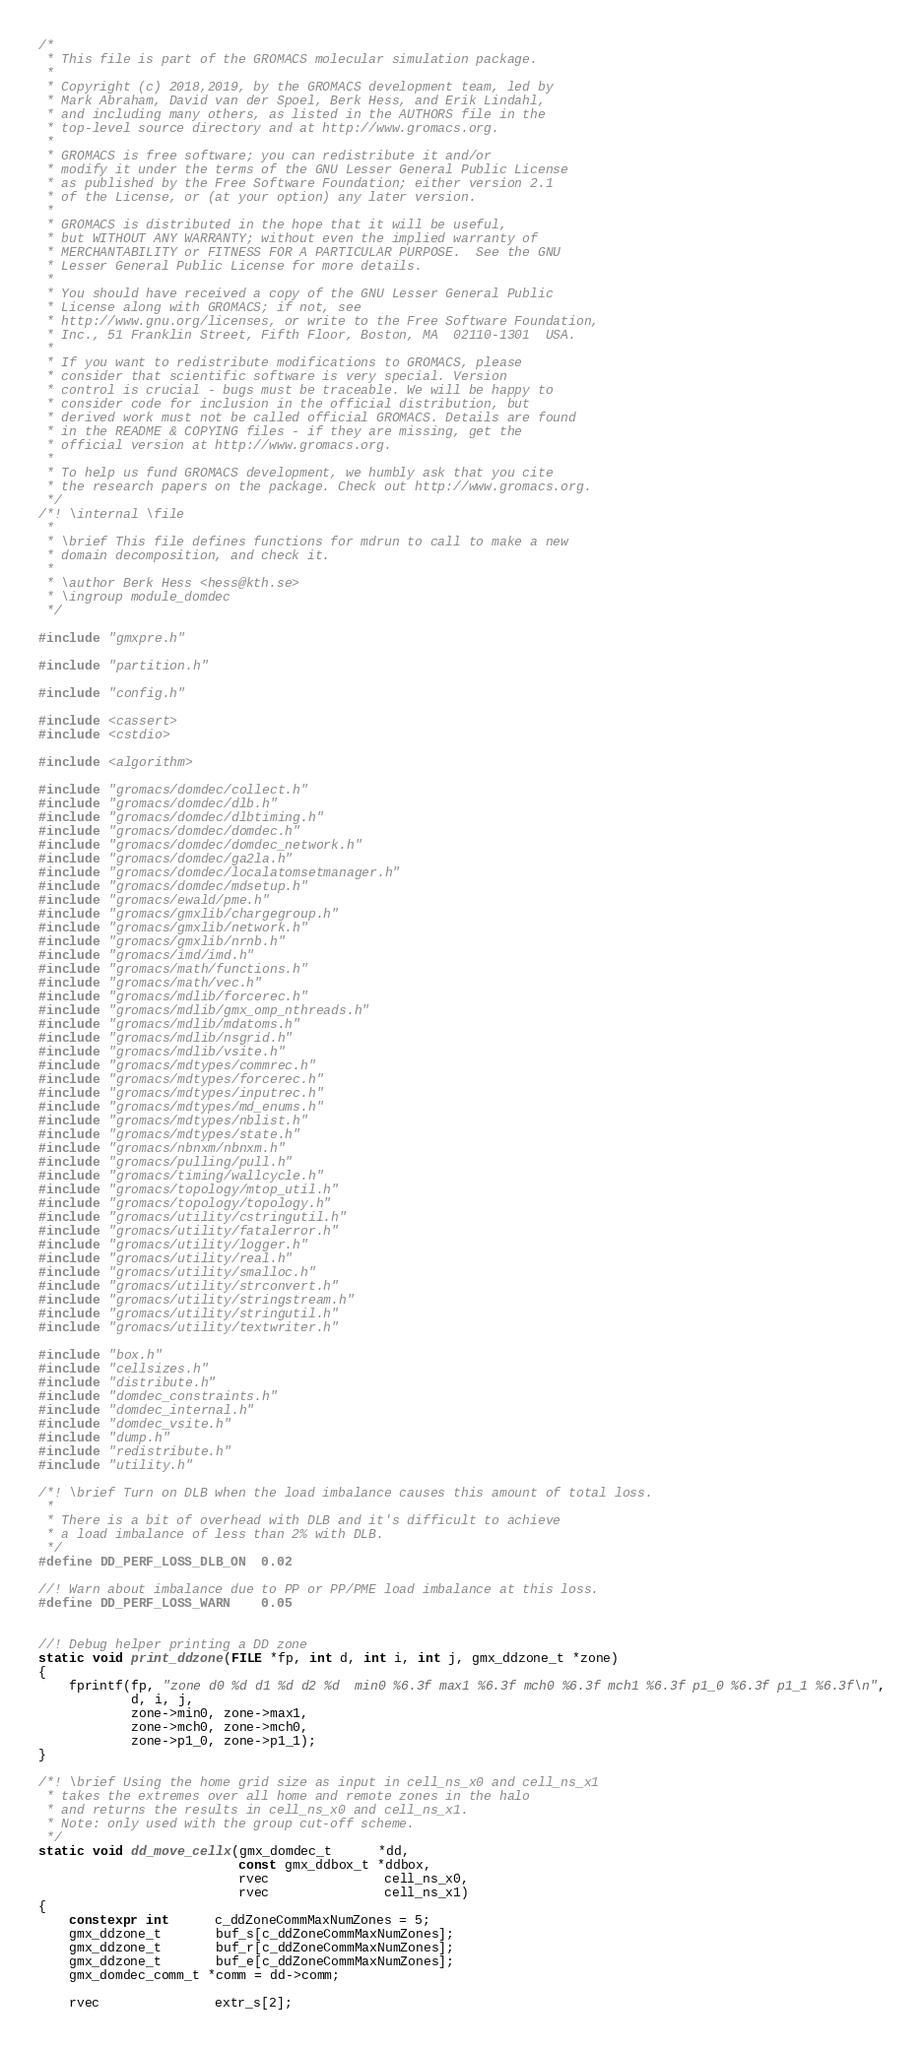Convert code to text. <code><loc_0><loc_0><loc_500><loc_500><_C++_>/*
 * This file is part of the GROMACS molecular simulation package.
 *
 * Copyright (c) 2018,2019, by the GROMACS development team, led by
 * Mark Abraham, David van der Spoel, Berk Hess, and Erik Lindahl,
 * and including many others, as listed in the AUTHORS file in the
 * top-level source directory and at http://www.gromacs.org.
 *
 * GROMACS is free software; you can redistribute it and/or
 * modify it under the terms of the GNU Lesser General Public License
 * as published by the Free Software Foundation; either version 2.1
 * of the License, or (at your option) any later version.
 *
 * GROMACS is distributed in the hope that it will be useful,
 * but WITHOUT ANY WARRANTY; without even the implied warranty of
 * MERCHANTABILITY or FITNESS FOR A PARTICULAR PURPOSE.  See the GNU
 * Lesser General Public License for more details.
 *
 * You should have received a copy of the GNU Lesser General Public
 * License along with GROMACS; if not, see
 * http://www.gnu.org/licenses, or write to the Free Software Foundation,
 * Inc., 51 Franklin Street, Fifth Floor, Boston, MA  02110-1301  USA.
 *
 * If you want to redistribute modifications to GROMACS, please
 * consider that scientific software is very special. Version
 * control is crucial - bugs must be traceable. We will be happy to
 * consider code for inclusion in the official distribution, but
 * derived work must not be called official GROMACS. Details are found
 * in the README & COPYING files - if they are missing, get the
 * official version at http://www.gromacs.org.
 *
 * To help us fund GROMACS development, we humbly ask that you cite
 * the research papers on the package. Check out http://www.gromacs.org.
 */
/*! \internal \file
 *
 * \brief This file defines functions for mdrun to call to make a new
 * domain decomposition, and check it.
 *
 * \author Berk Hess <hess@kth.se>
 * \ingroup module_domdec
 */

#include "gmxpre.h"

#include "partition.h"

#include "config.h"

#include <cassert>
#include <cstdio>

#include <algorithm>

#include "gromacs/domdec/collect.h"
#include "gromacs/domdec/dlb.h"
#include "gromacs/domdec/dlbtiming.h"
#include "gromacs/domdec/domdec.h"
#include "gromacs/domdec/domdec_network.h"
#include "gromacs/domdec/ga2la.h"
#include "gromacs/domdec/localatomsetmanager.h"
#include "gromacs/domdec/mdsetup.h"
#include "gromacs/ewald/pme.h"
#include "gromacs/gmxlib/chargegroup.h"
#include "gromacs/gmxlib/network.h"
#include "gromacs/gmxlib/nrnb.h"
#include "gromacs/imd/imd.h"
#include "gromacs/math/functions.h"
#include "gromacs/math/vec.h"
#include "gromacs/mdlib/forcerec.h"
#include "gromacs/mdlib/gmx_omp_nthreads.h"
#include "gromacs/mdlib/mdatoms.h"
#include "gromacs/mdlib/nsgrid.h"
#include "gromacs/mdlib/vsite.h"
#include "gromacs/mdtypes/commrec.h"
#include "gromacs/mdtypes/forcerec.h"
#include "gromacs/mdtypes/inputrec.h"
#include "gromacs/mdtypes/md_enums.h"
#include "gromacs/mdtypes/nblist.h"
#include "gromacs/mdtypes/state.h"
#include "gromacs/nbnxm/nbnxm.h"
#include "gromacs/pulling/pull.h"
#include "gromacs/timing/wallcycle.h"
#include "gromacs/topology/mtop_util.h"
#include "gromacs/topology/topology.h"
#include "gromacs/utility/cstringutil.h"
#include "gromacs/utility/fatalerror.h"
#include "gromacs/utility/logger.h"
#include "gromacs/utility/real.h"
#include "gromacs/utility/smalloc.h"
#include "gromacs/utility/strconvert.h"
#include "gromacs/utility/stringstream.h"
#include "gromacs/utility/stringutil.h"
#include "gromacs/utility/textwriter.h"

#include "box.h"
#include "cellsizes.h"
#include "distribute.h"
#include "domdec_constraints.h"
#include "domdec_internal.h"
#include "domdec_vsite.h"
#include "dump.h"
#include "redistribute.h"
#include "utility.h"

/*! \brief Turn on DLB when the load imbalance causes this amount of total loss.
 *
 * There is a bit of overhead with DLB and it's difficult to achieve
 * a load imbalance of less than 2% with DLB.
 */
#define DD_PERF_LOSS_DLB_ON  0.02

//! Warn about imbalance due to PP or PP/PME load imbalance at this loss.
#define DD_PERF_LOSS_WARN    0.05


//! Debug helper printing a DD zone
static void print_ddzone(FILE *fp, int d, int i, int j, gmx_ddzone_t *zone)
{
    fprintf(fp, "zone d0 %d d1 %d d2 %d  min0 %6.3f max1 %6.3f mch0 %6.3f mch1 %6.3f p1_0 %6.3f p1_1 %6.3f\n",
            d, i, j,
            zone->min0, zone->max1,
            zone->mch0, zone->mch0,
            zone->p1_0, zone->p1_1);
}

/*! \brief Using the home grid size as input in cell_ns_x0 and cell_ns_x1
 * takes the extremes over all home and remote zones in the halo
 * and returns the results in cell_ns_x0 and cell_ns_x1.
 * Note: only used with the group cut-off scheme.
 */
static void dd_move_cellx(gmx_domdec_t      *dd,
                          const gmx_ddbox_t *ddbox,
                          rvec               cell_ns_x0,
                          rvec               cell_ns_x1)
{
    constexpr int      c_ddZoneCommMaxNumZones = 5;
    gmx_ddzone_t       buf_s[c_ddZoneCommMaxNumZones];
    gmx_ddzone_t       buf_r[c_ddZoneCommMaxNumZones];
    gmx_ddzone_t       buf_e[c_ddZoneCommMaxNumZones];
    gmx_domdec_comm_t *comm = dd->comm;

    rvec               extr_s[2];</code> 